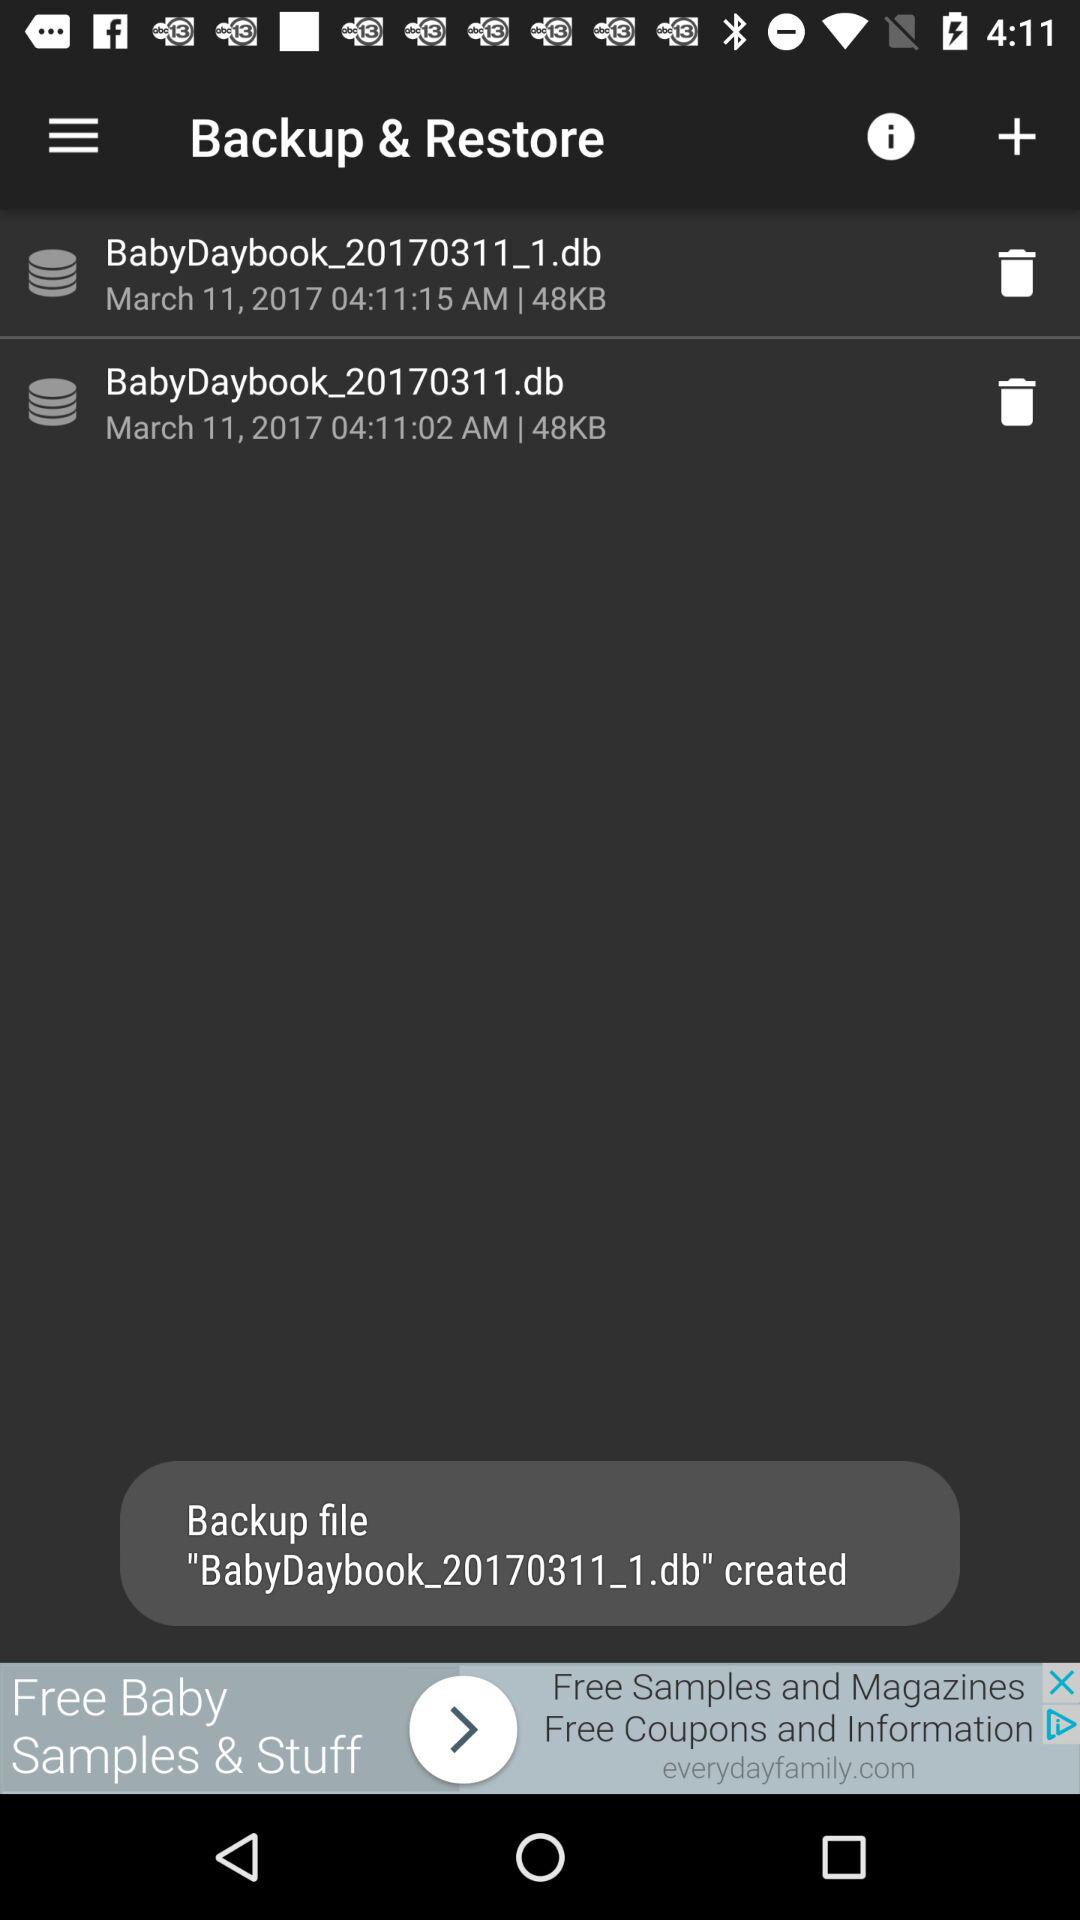How many bytes is the smaller backup?
Answer the question using a single word or phrase. 48KB 